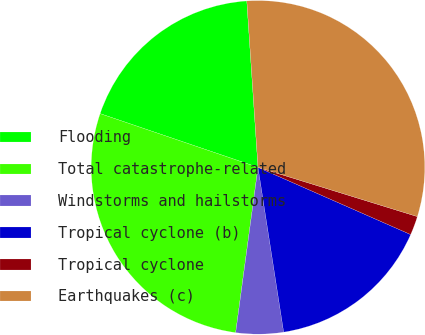<chart> <loc_0><loc_0><loc_500><loc_500><pie_chart><fcel>Flooding<fcel>Total catastrophe-related<fcel>Windstorms and hailstorms<fcel>Tropical cyclone (b)<fcel>Tropical cyclone<fcel>Earthquakes (c)<nl><fcel>18.71%<fcel>28.08%<fcel>4.6%<fcel>15.94%<fcel>1.83%<fcel>30.84%<nl></chart> 